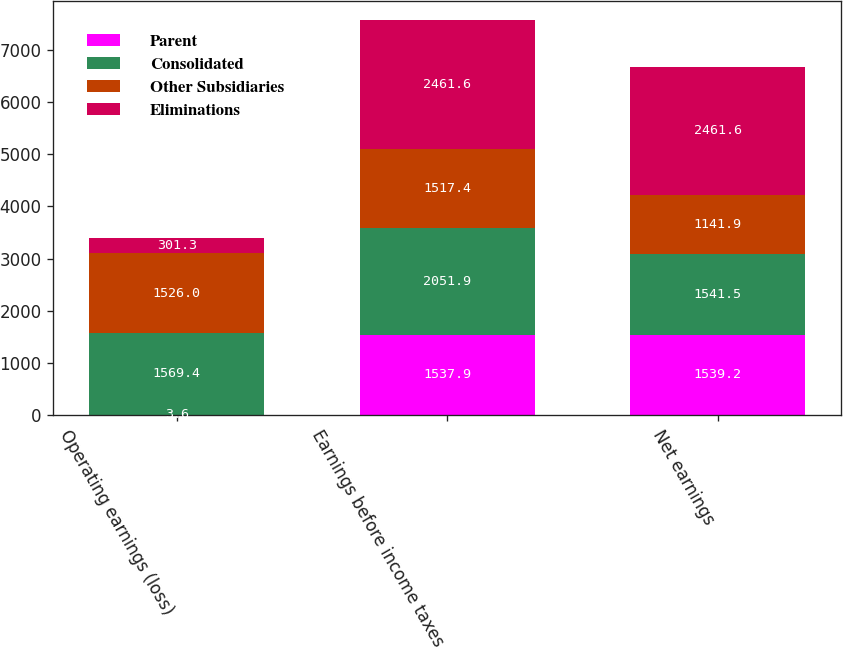Convert chart to OTSL. <chart><loc_0><loc_0><loc_500><loc_500><stacked_bar_chart><ecel><fcel>Operating earnings (loss)<fcel>Earnings before income taxes<fcel>Net earnings<nl><fcel>Parent<fcel>3.6<fcel>1537.9<fcel>1539.2<nl><fcel>Consolidated<fcel>1569.4<fcel>2051.9<fcel>1541.5<nl><fcel>Other Subsidiaries<fcel>1526<fcel>1517.4<fcel>1141.9<nl><fcel>Eliminations<fcel>301.3<fcel>2461.6<fcel>2461.6<nl></chart> 